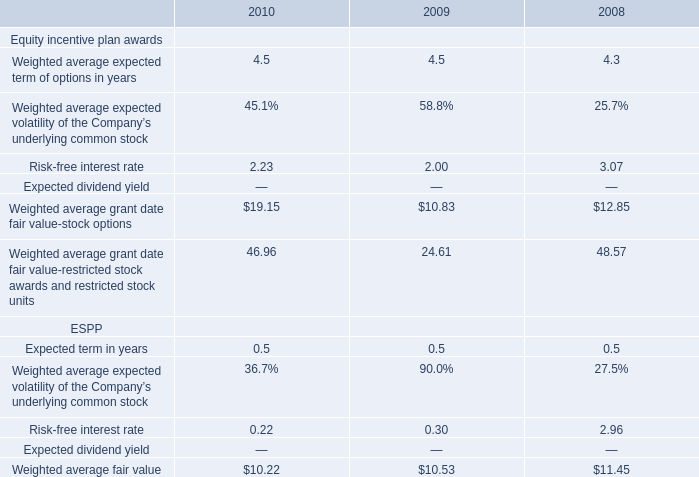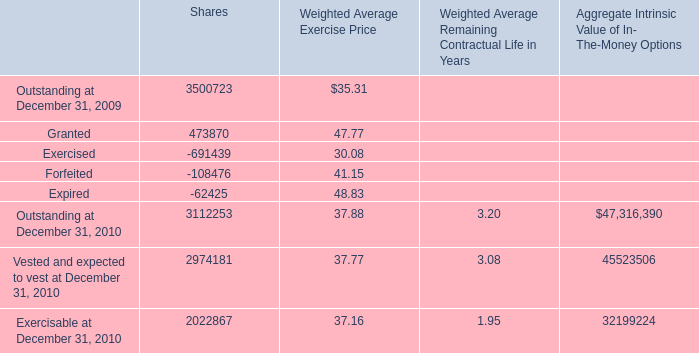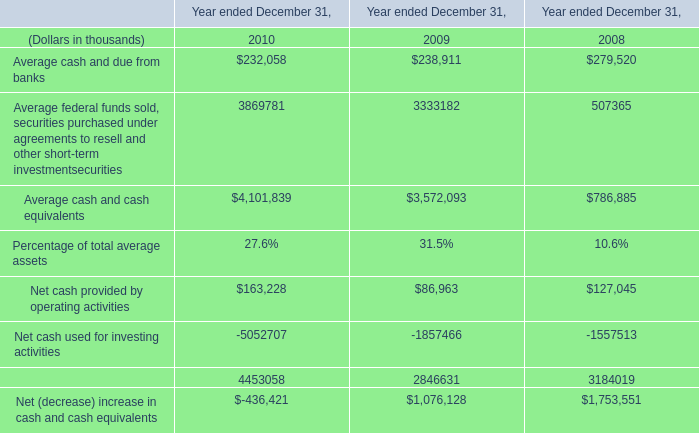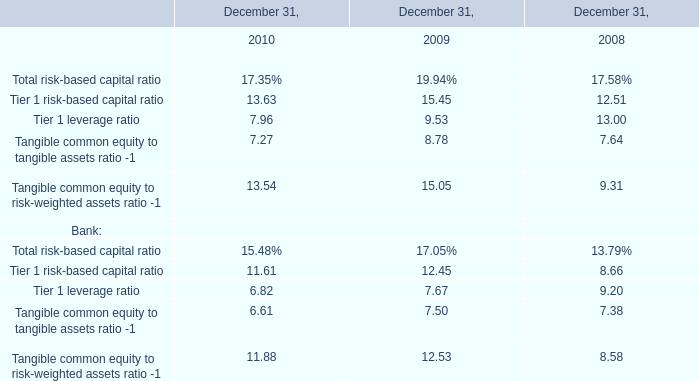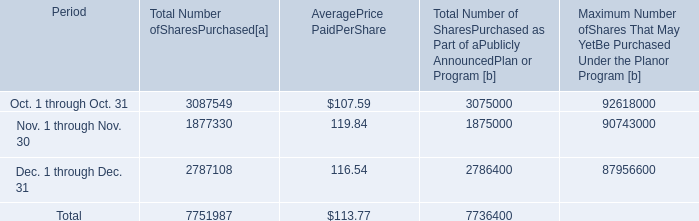What is the total amount of Dec. 1 through Dec. 31 of [EMPTY].2, and Outstanding at December 31, 2010 of Shares ? 
Computations: (2786400.0 + 3112253.0)
Answer: 5898653.0. 